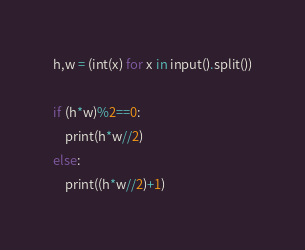<code> <loc_0><loc_0><loc_500><loc_500><_Python_>h,w = (int(x) for x in input().split())
 
if (h*w)%2==0:
    print(h*w//2)
else:
    print((h*w//2)+1)</code> 